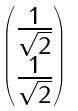Convert formula to latex. <formula><loc_0><loc_0><loc_500><loc_500>\begin{pmatrix} \frac { 1 } { \sqrt { 2 } } \\ \frac { 1 } { \sqrt { 2 } } \end{pmatrix}</formula> 